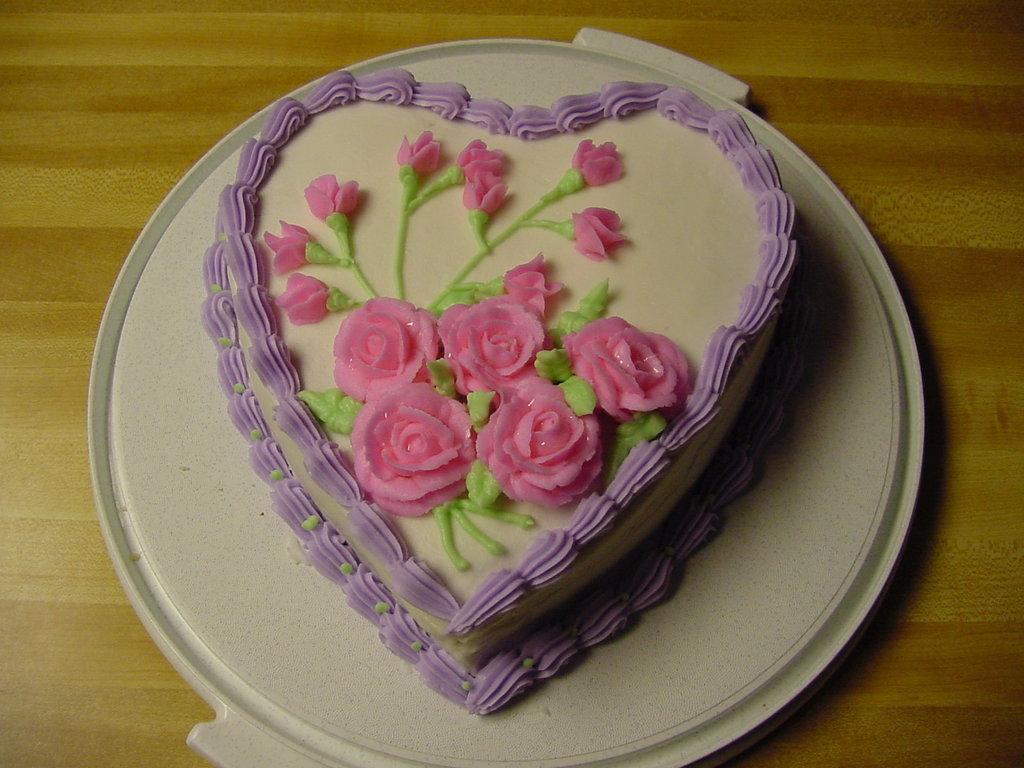In one or two sentences, can you explain what this image depicts? In the image there is a cake placed on a plate and kept on a table. 